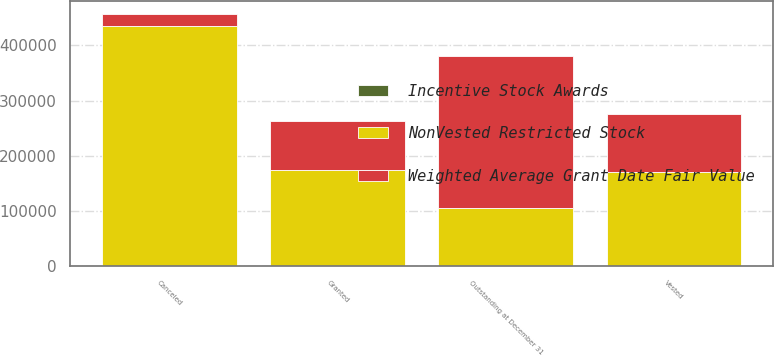<chart> <loc_0><loc_0><loc_500><loc_500><stacked_bar_chart><ecel><fcel>Outstanding at December 31<fcel>Granted<fcel>Vested<fcel>Canceled<nl><fcel>Weighted Average Grant Date Fair Value<fcel>274609<fcel>89500<fcel>105833<fcel>22175<nl><fcel>NonVested Restricted Stock<fcel>105833<fcel>174000<fcel>170334<fcel>435540<nl><fcel>Incentive Stock Awards<fcel>44.04<fcel>29<fcel>36.39<fcel>34.7<nl></chart> 